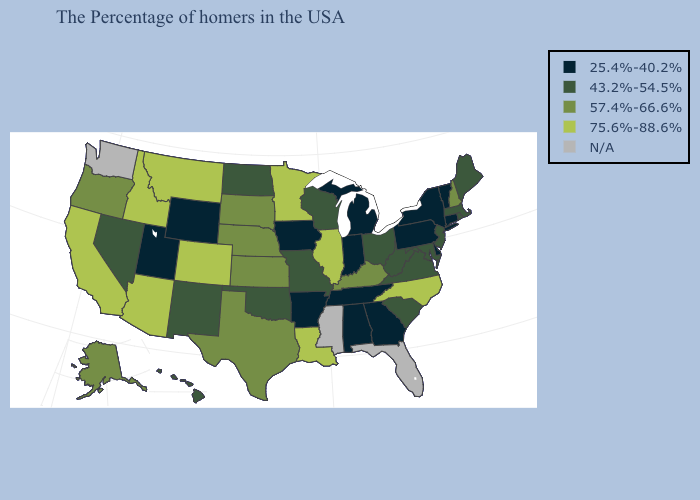Name the states that have a value in the range 25.4%-40.2%?
Short answer required. Vermont, Connecticut, New York, Delaware, Pennsylvania, Georgia, Michigan, Indiana, Alabama, Tennessee, Arkansas, Iowa, Wyoming, Utah. Name the states that have a value in the range 43.2%-54.5%?
Answer briefly. Maine, Massachusetts, Rhode Island, New Jersey, Maryland, Virginia, South Carolina, West Virginia, Ohio, Wisconsin, Missouri, Oklahoma, North Dakota, New Mexico, Nevada, Hawaii. Does the first symbol in the legend represent the smallest category?
Keep it brief. Yes. Name the states that have a value in the range 57.4%-66.6%?
Give a very brief answer. New Hampshire, Kentucky, Kansas, Nebraska, Texas, South Dakota, Oregon, Alaska. Name the states that have a value in the range 43.2%-54.5%?
Keep it brief. Maine, Massachusetts, Rhode Island, New Jersey, Maryland, Virginia, South Carolina, West Virginia, Ohio, Wisconsin, Missouri, Oklahoma, North Dakota, New Mexico, Nevada, Hawaii. Which states hav the highest value in the Northeast?
Concise answer only. New Hampshire. Which states have the lowest value in the South?
Short answer required. Delaware, Georgia, Alabama, Tennessee, Arkansas. What is the highest value in the West ?
Give a very brief answer. 75.6%-88.6%. What is the highest value in states that border North Dakota?
Answer briefly. 75.6%-88.6%. Does Nebraska have the highest value in the USA?
Give a very brief answer. No. What is the highest value in the USA?
Keep it brief. 75.6%-88.6%. Name the states that have a value in the range 57.4%-66.6%?
Answer briefly. New Hampshire, Kentucky, Kansas, Nebraska, Texas, South Dakota, Oregon, Alaska. What is the highest value in states that border Virginia?
Answer briefly. 75.6%-88.6%. 